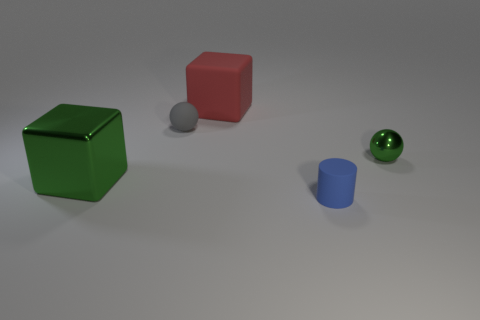Add 4 brown rubber balls. How many objects exist? 9 Subtract 1 balls. How many balls are left? 1 Add 4 tiny blue cylinders. How many tiny blue cylinders are left? 5 Add 1 big green metal spheres. How many big green metal spheres exist? 1 Subtract 1 green blocks. How many objects are left? 4 Subtract all cubes. How many objects are left? 3 Subtract all gray cylinders. Subtract all gray blocks. How many cylinders are left? 1 Subtract all cyan blocks. How many gray spheres are left? 1 Subtract all big green matte balls. Subtract all blue matte things. How many objects are left? 4 